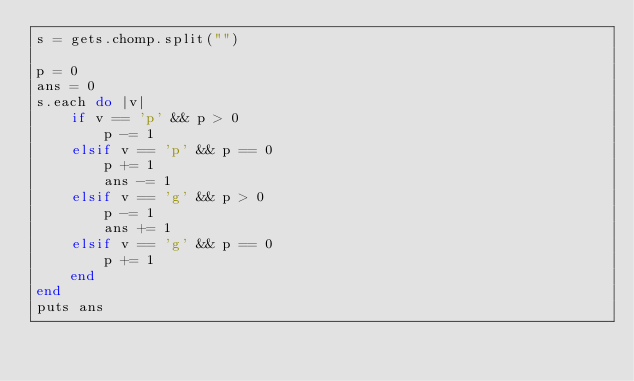<code> <loc_0><loc_0><loc_500><loc_500><_Ruby_>s = gets.chomp.split("")

p = 0
ans = 0
s.each do |v|
    if v == 'p' && p > 0
        p -= 1
    elsif v == 'p' && p == 0
        p += 1
        ans -= 1
    elsif v == 'g' && p > 0
        p -= 1
        ans += 1
    elsif v == 'g' && p == 0
        p += 1
    end
end
puts ans</code> 